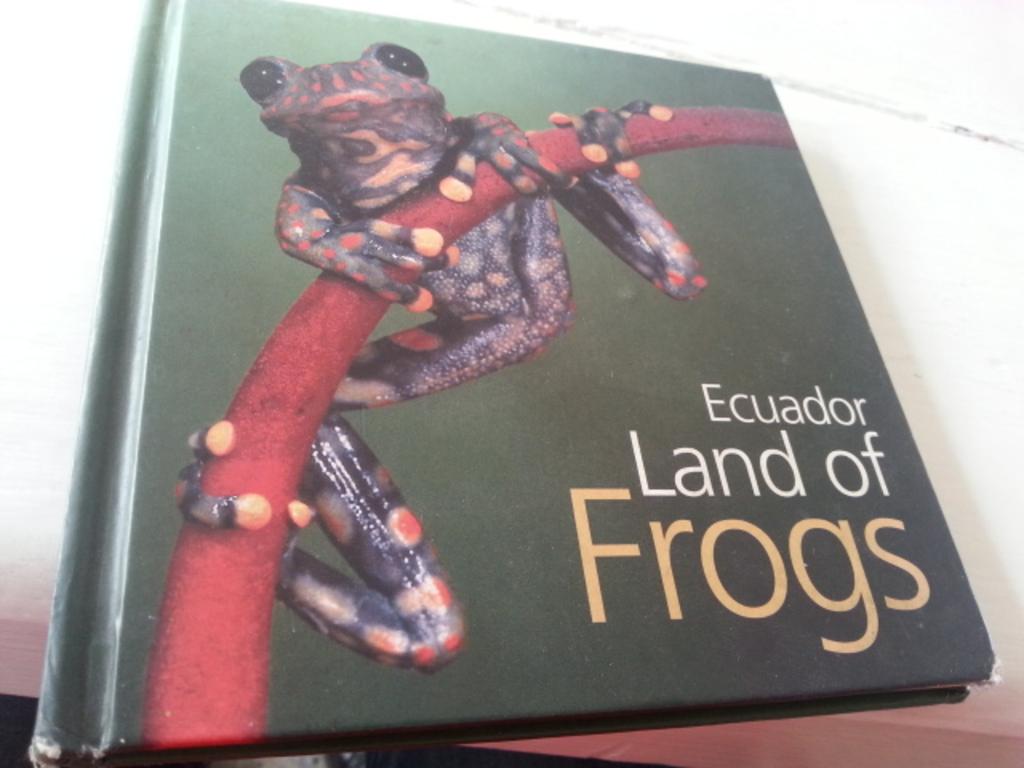What country does the book say is the land of frogs?
Offer a very short reply. Ecuador. 